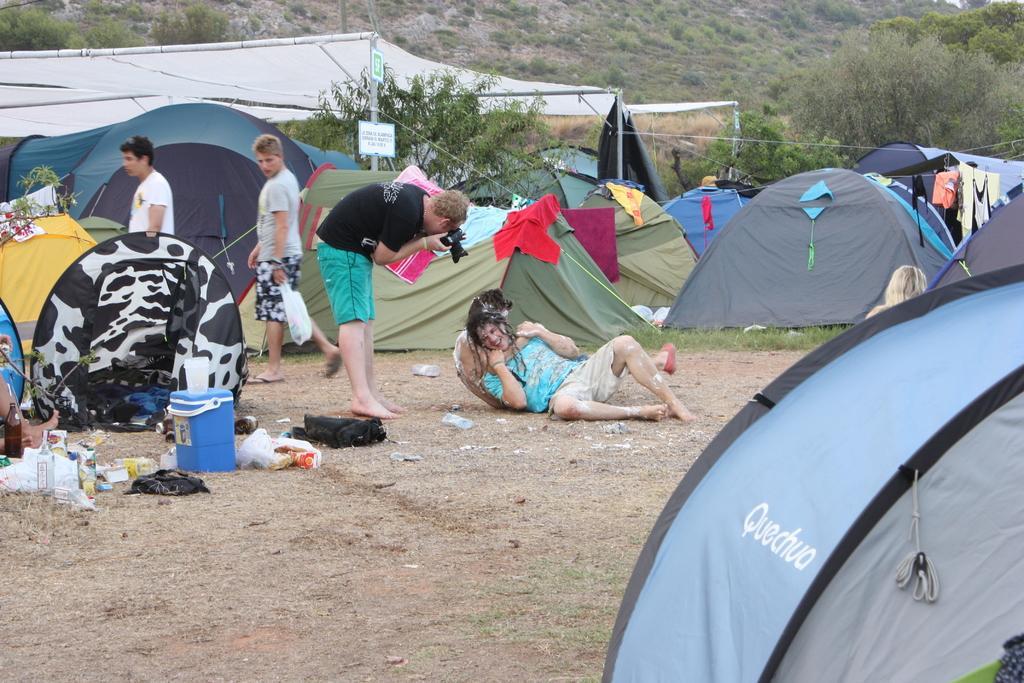Could you give a brief overview of what you see in this image? In this image, we can see people and tents. In the middle of the image, we can see a person holding another person. Beside them, we can see a man holding a camera. On the left side of the image, we can see a person holding a carry bag and walking through the walkway. We can see a few bottles, some objects and basket on the ground. In the background, there are trees, tents, poles, grass, boards and plants. 